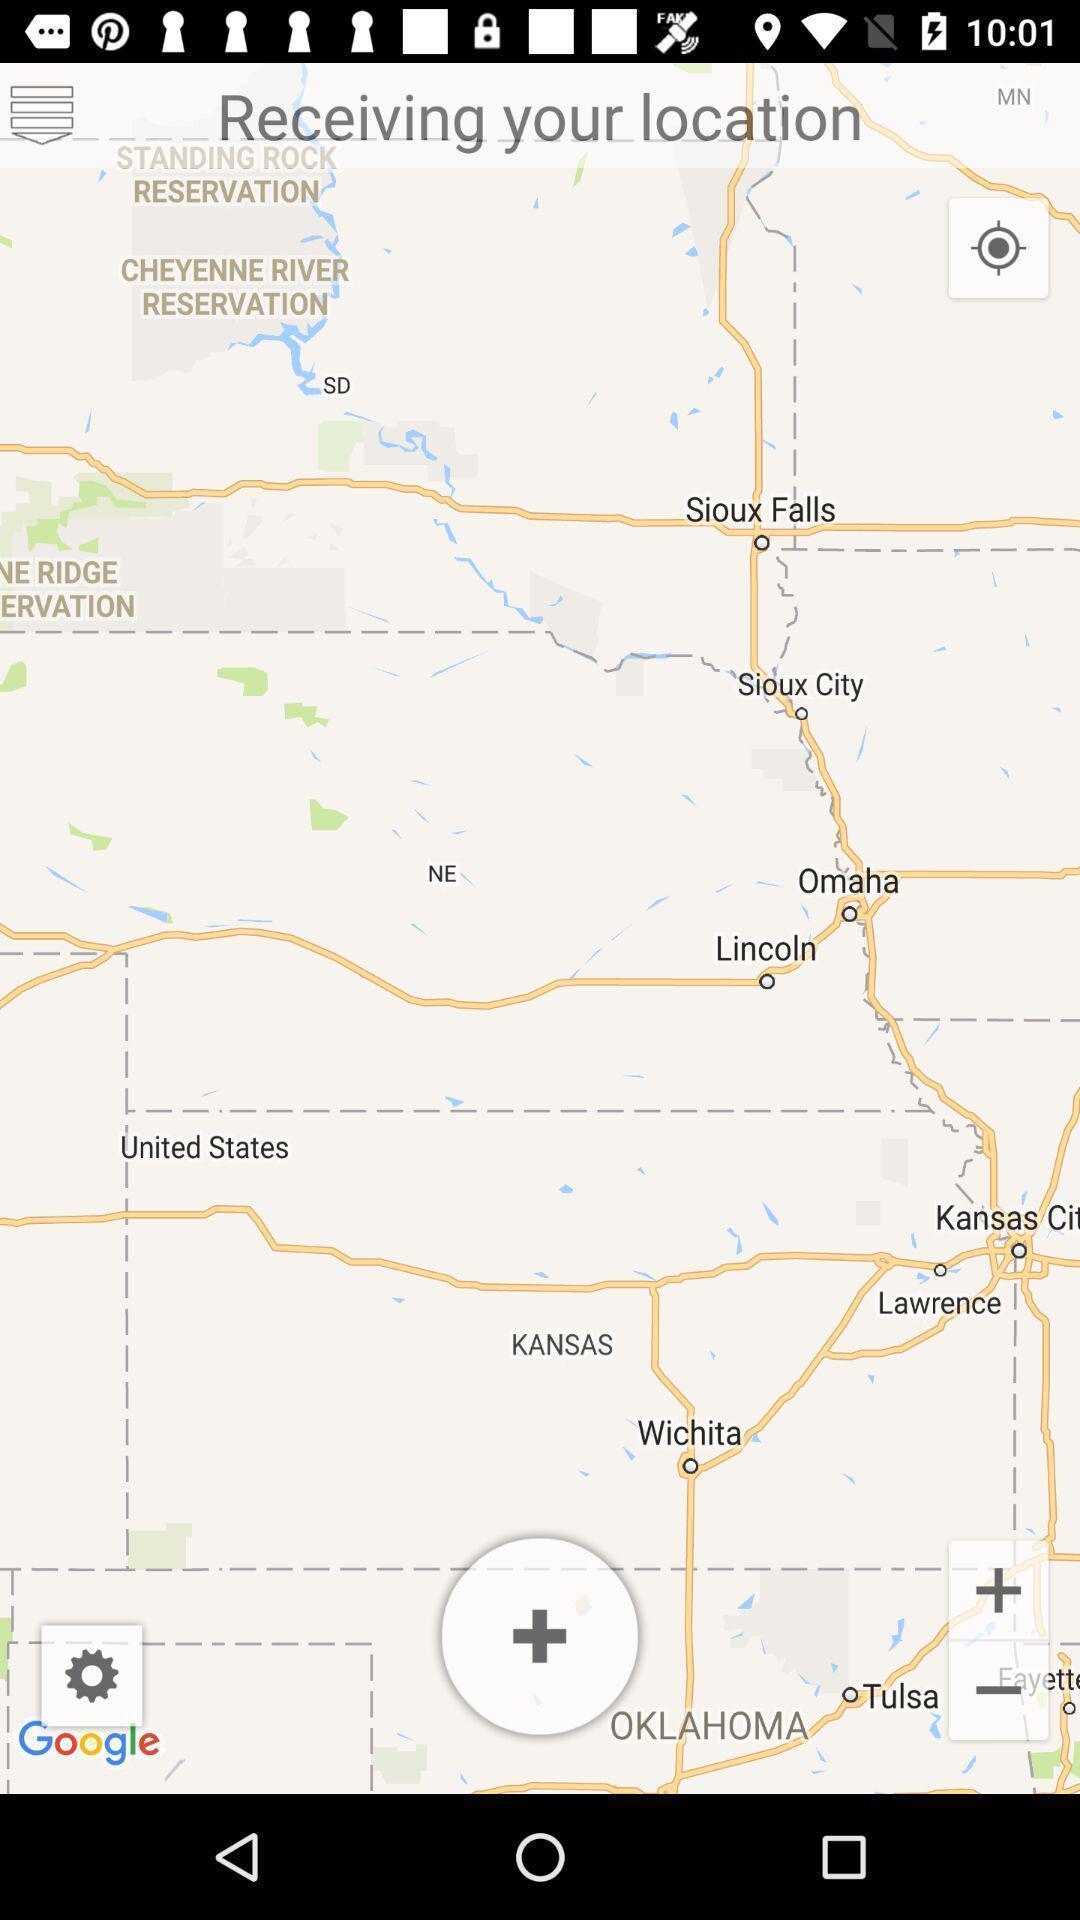Provide a description of this screenshot. Receiving location in a map. 